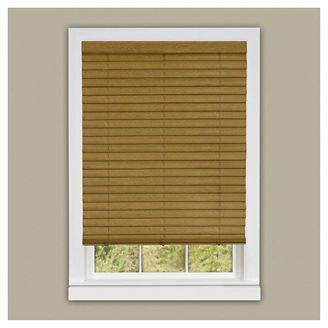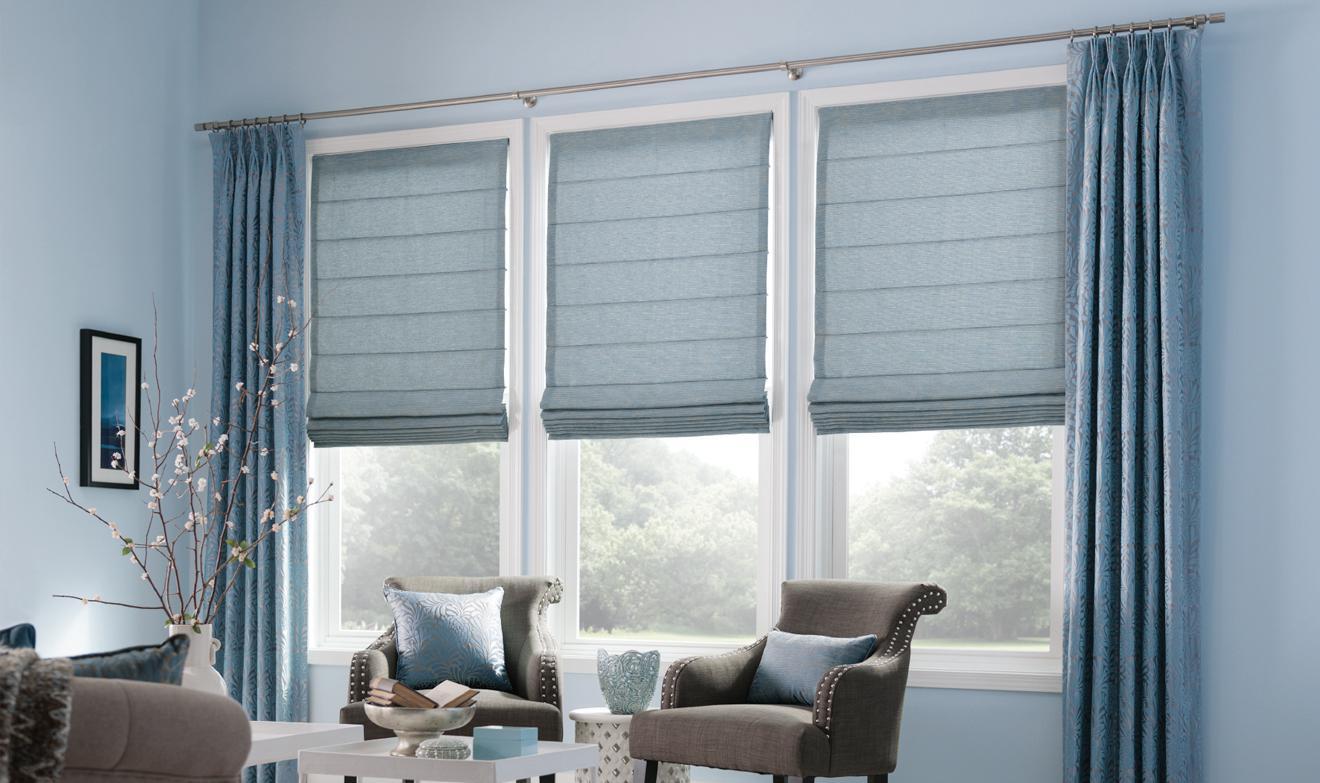The first image is the image on the left, the second image is the image on the right. Evaluate the accuracy of this statement regarding the images: "One image is just a window, while the other is a room.". Is it true? Answer yes or no. Yes. The first image is the image on the left, the second image is the image on the right. Assess this claim about the two images: "In at least one image there are three blue shades partly open.". Correct or not? Answer yes or no. Yes. 